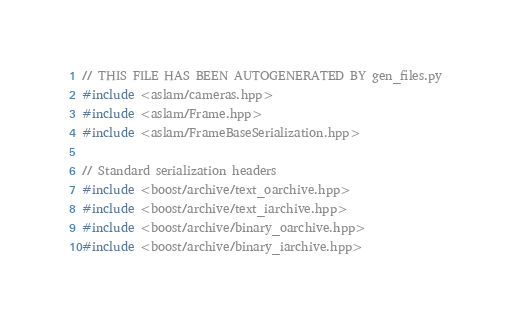<code> <loc_0><loc_0><loc_500><loc_500><_C++_>// THIS FILE HAS BEEN AUTOGENERATED BY gen_files.py
#include <aslam/cameras.hpp>
#include <aslam/Frame.hpp>
#include <aslam/FrameBaseSerialization.hpp>

// Standard serialization headers
#include <boost/archive/text_oarchive.hpp>
#include <boost/archive/text_iarchive.hpp>
#include <boost/archive/binary_oarchive.hpp>
#include <boost/archive/binary_iarchive.hpp></code> 